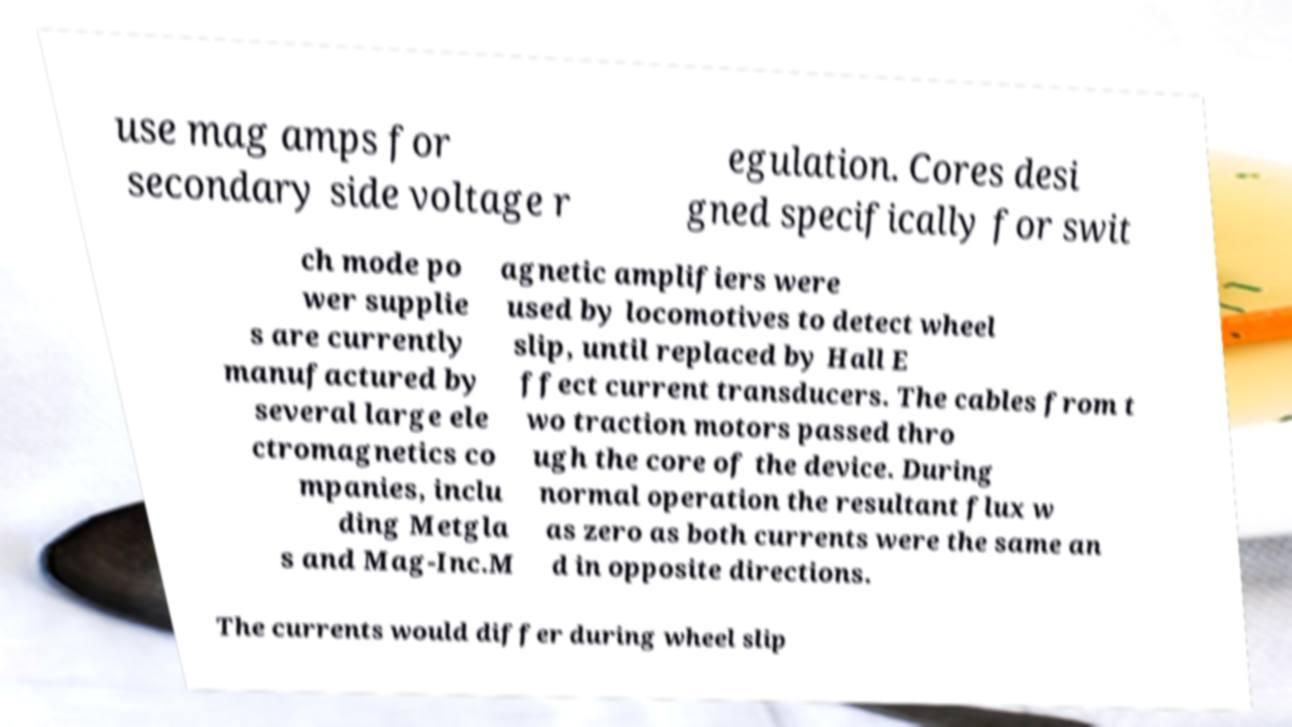Could you extract and type out the text from this image? use mag amps for secondary side voltage r egulation. Cores desi gned specifically for swit ch mode po wer supplie s are currently manufactured by several large ele ctromagnetics co mpanies, inclu ding Metgla s and Mag-Inc.M agnetic amplifiers were used by locomotives to detect wheel slip, until replaced by Hall E ffect current transducers. The cables from t wo traction motors passed thro ugh the core of the device. During normal operation the resultant flux w as zero as both currents were the same an d in opposite directions. The currents would differ during wheel slip 